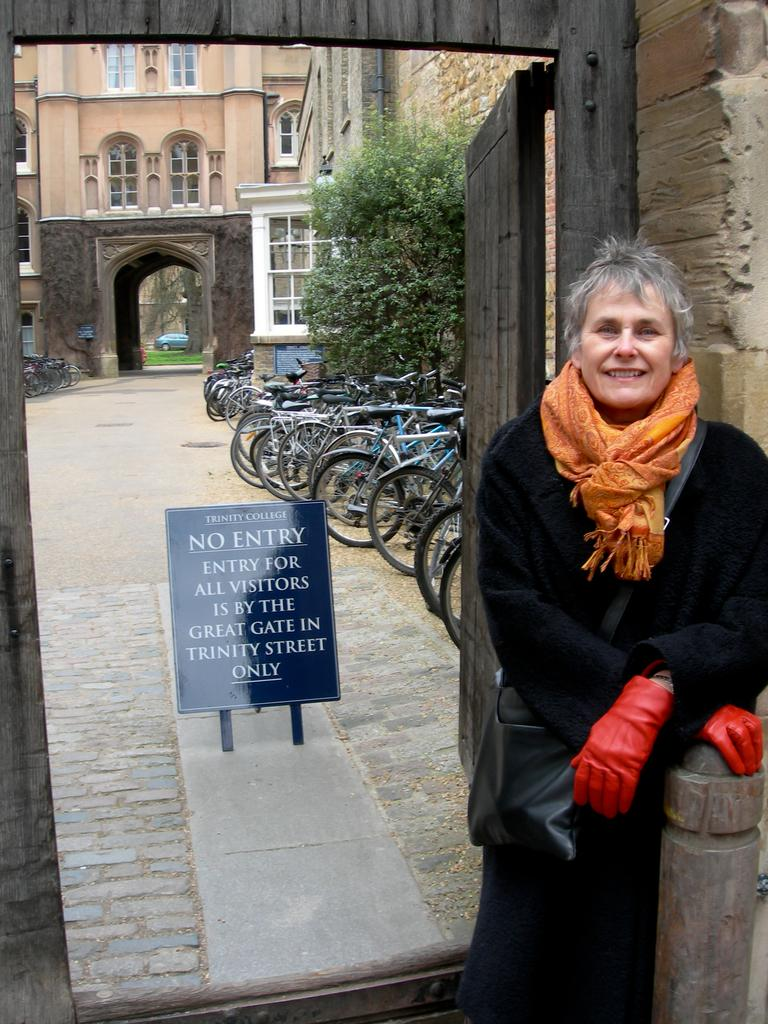What is the woman in the image doing? The woman is standing and smiling in the image. What type of vehicles are present in the image? There are bicycles in the image. What object can be seen in the image that might be used for displaying information or messages? There is a board in the image. What type of structures can be seen in the image? There are buildings with windows in the image. What type of plant is visible in the image? There is a tree in the image. What type of vehicle can be seen in the background of the image? There is a car visible in the background of the image. How does the woman trip over the bicycle in the image? The woman does not trip over a bicycle in the image; she is standing and smiling. 